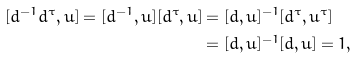<formula> <loc_0><loc_0><loc_500><loc_500>[ d ^ { - 1 } d ^ { \tau } , u ] = [ d ^ { - 1 } , u ] [ d ^ { \tau } , u ] & = [ d , u ] ^ { - 1 } [ d ^ { \tau } , u ^ { \tau } ] \\ & = [ d , u ] ^ { - 1 } [ d , u ] = 1 ,</formula> 